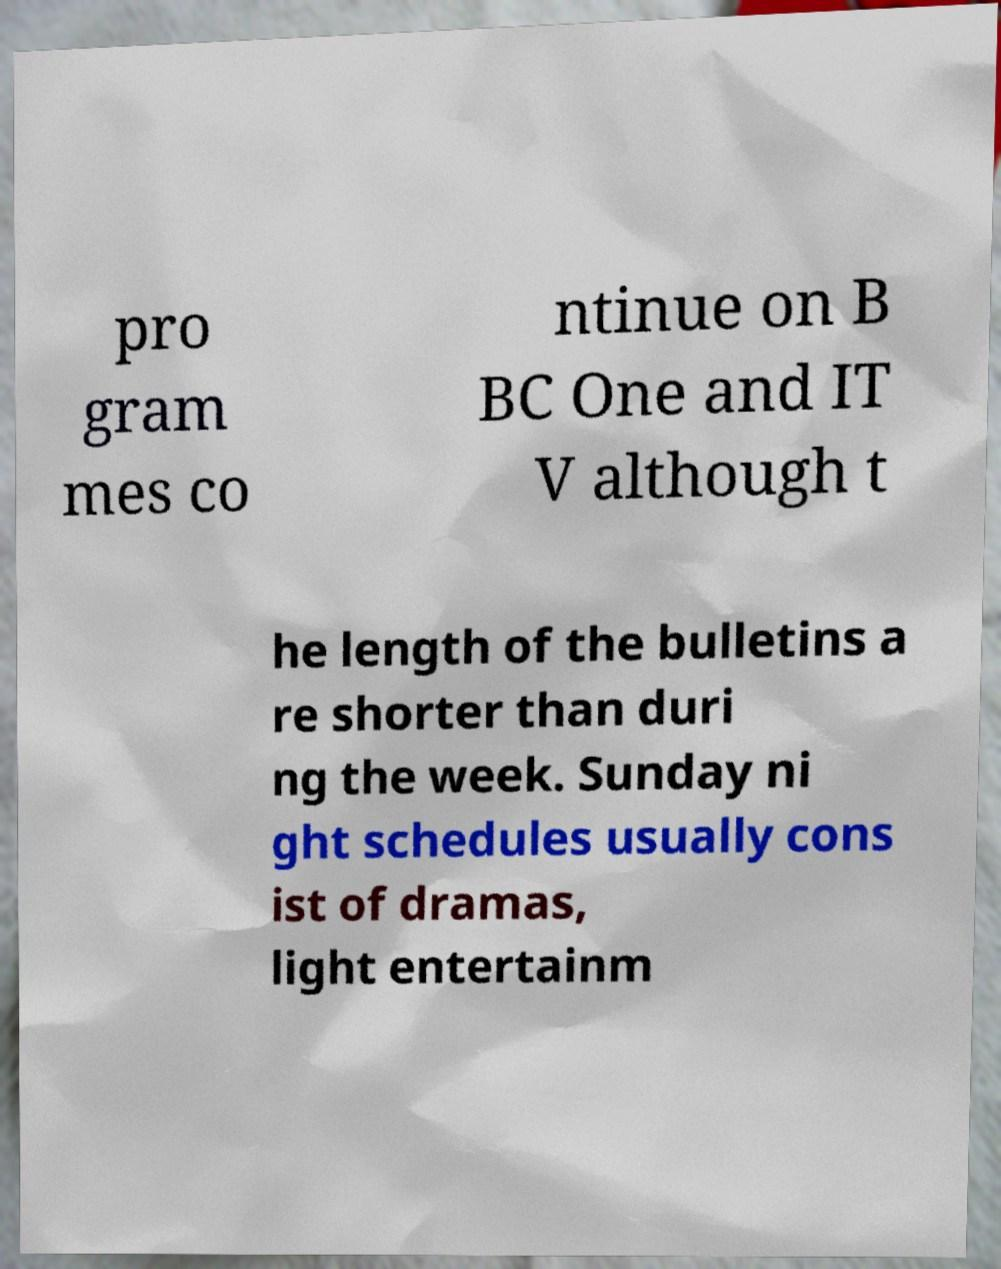I need the written content from this picture converted into text. Can you do that? pro gram mes co ntinue on B BC One and IT V although t he length of the bulletins a re shorter than duri ng the week. Sunday ni ght schedules usually cons ist of dramas, light entertainm 